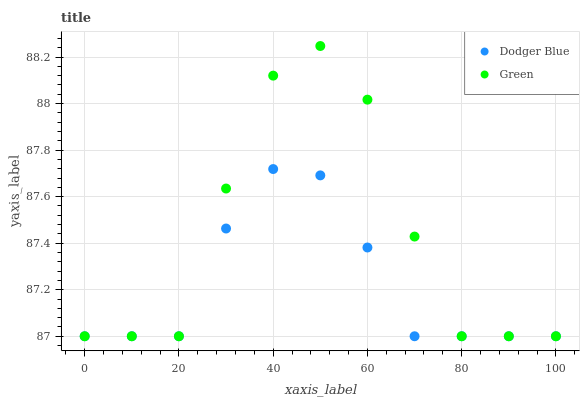Does Dodger Blue have the minimum area under the curve?
Answer yes or no. Yes. Does Green have the maximum area under the curve?
Answer yes or no. Yes. Does Dodger Blue have the maximum area under the curve?
Answer yes or no. No. Is Dodger Blue the smoothest?
Answer yes or no. Yes. Is Green the roughest?
Answer yes or no. Yes. Is Dodger Blue the roughest?
Answer yes or no. No. Does Green have the lowest value?
Answer yes or no. Yes. Does Green have the highest value?
Answer yes or no. Yes. Does Dodger Blue have the highest value?
Answer yes or no. No. Does Green intersect Dodger Blue?
Answer yes or no. Yes. Is Green less than Dodger Blue?
Answer yes or no. No. Is Green greater than Dodger Blue?
Answer yes or no. No. 